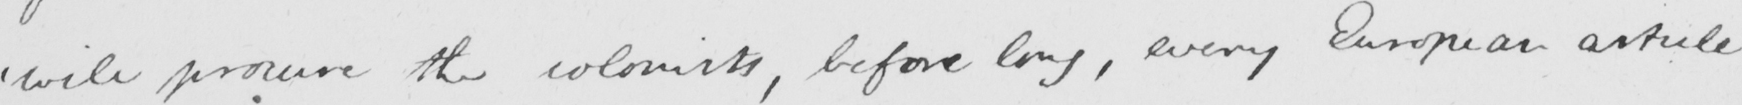Can you read and transcribe this handwriting? ' will promise the colonists , before long , every European article 